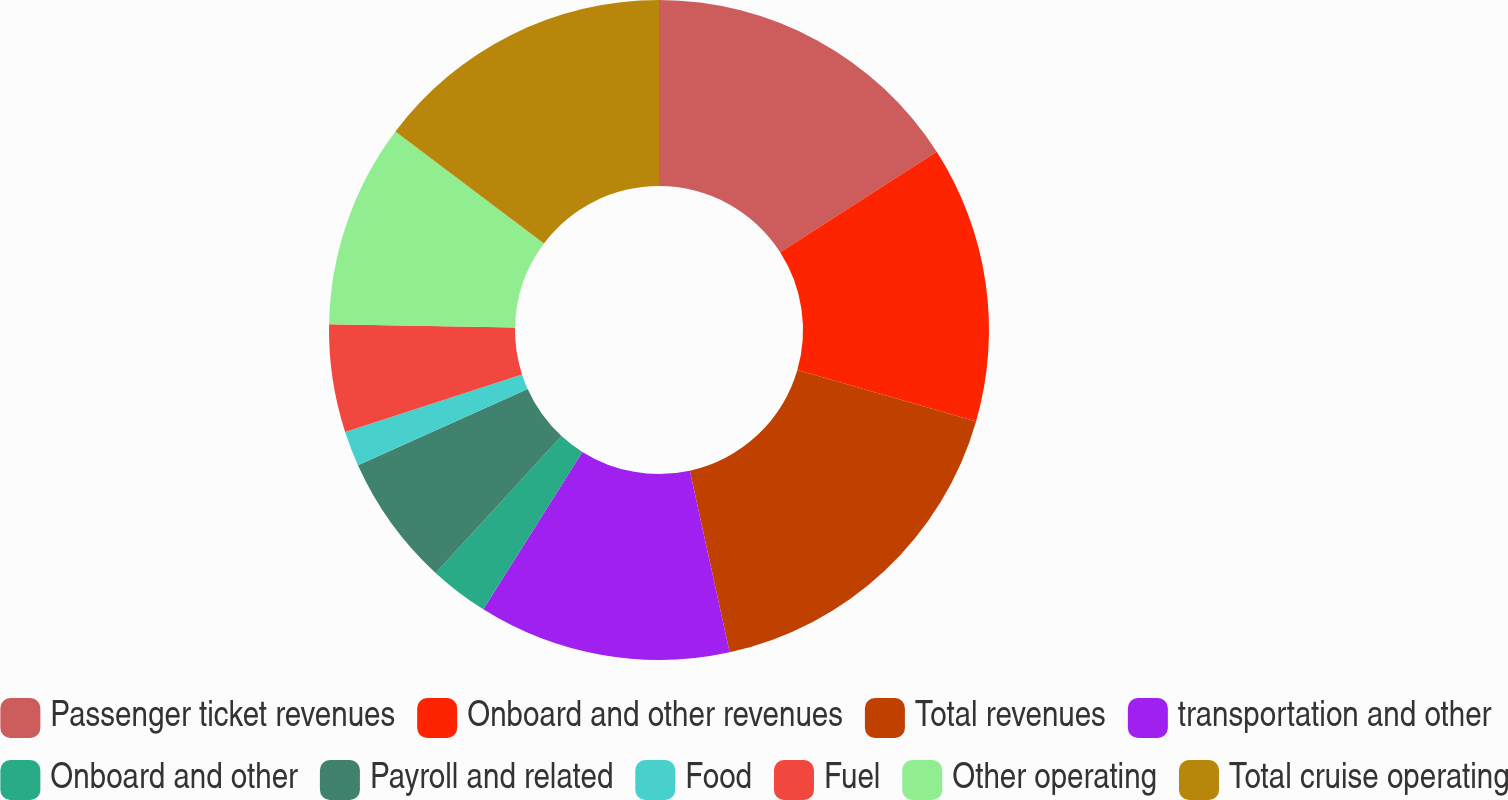Convert chart to OTSL. <chart><loc_0><loc_0><loc_500><loc_500><pie_chart><fcel>Passenger ticket revenues<fcel>Onboard and other revenues<fcel>Total revenues<fcel>transportation and other<fcel>Onboard and other<fcel>Payroll and related<fcel>Food<fcel>Fuel<fcel>Other operating<fcel>Total cruise operating<nl><fcel>15.92%<fcel>13.55%<fcel>17.1%<fcel>12.37%<fcel>2.9%<fcel>6.45%<fcel>1.72%<fcel>5.27%<fcel>10.0%<fcel>14.73%<nl></chart> 